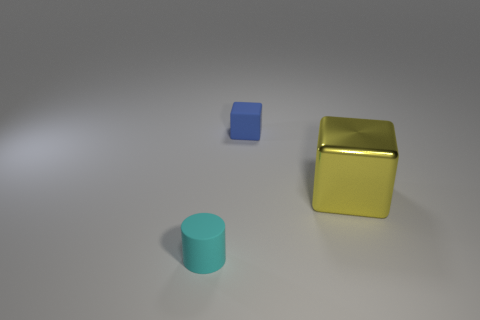The tiny object left of the small thing that is behind the tiny cyan cylinder is what color?
Provide a succinct answer. Cyan. Are the cyan thing and the tiny object to the right of the small cyan rubber cylinder made of the same material?
Your response must be concise. Yes. There is a tiny rubber thing behind the tiny thing that is in front of the tiny thing that is to the right of the tiny cyan cylinder; what color is it?
Make the answer very short. Blue. Are there any other things that have the same shape as the tiny cyan thing?
Make the answer very short. No. Is the number of blocks greater than the number of cyan rubber objects?
Ensure brevity in your answer.  Yes. What number of things are both in front of the large shiny thing and behind the cyan thing?
Make the answer very short. 0. There is a object that is to the left of the small rubber block; what number of small rubber things are on the left side of it?
Ensure brevity in your answer.  0. There is a cyan rubber thing that is on the left side of the yellow object; is its size the same as the block to the right of the blue thing?
Provide a short and direct response. No. What number of big brown shiny cubes are there?
Provide a succinct answer. 0. How many other cyan cylinders have the same material as the cylinder?
Your response must be concise. 0. 